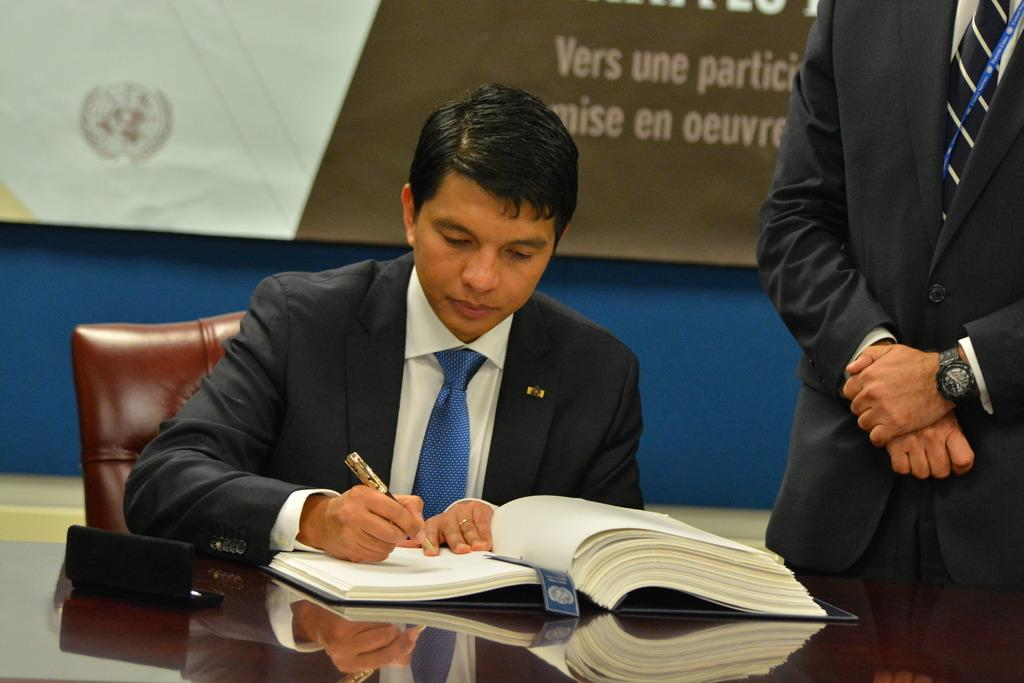What is the seated person doing in the image? The person sitting on a chair is writing in a book. What else can be seen on the table in the image? There is a book and a box on the table. What is hanging on the wall in the image? There is a banner on the wall. Can you describe the other person in the image? Another person is standing beside the seated person. How many girls are teaching in the image? There is no indication of teaching or girls in the image. 